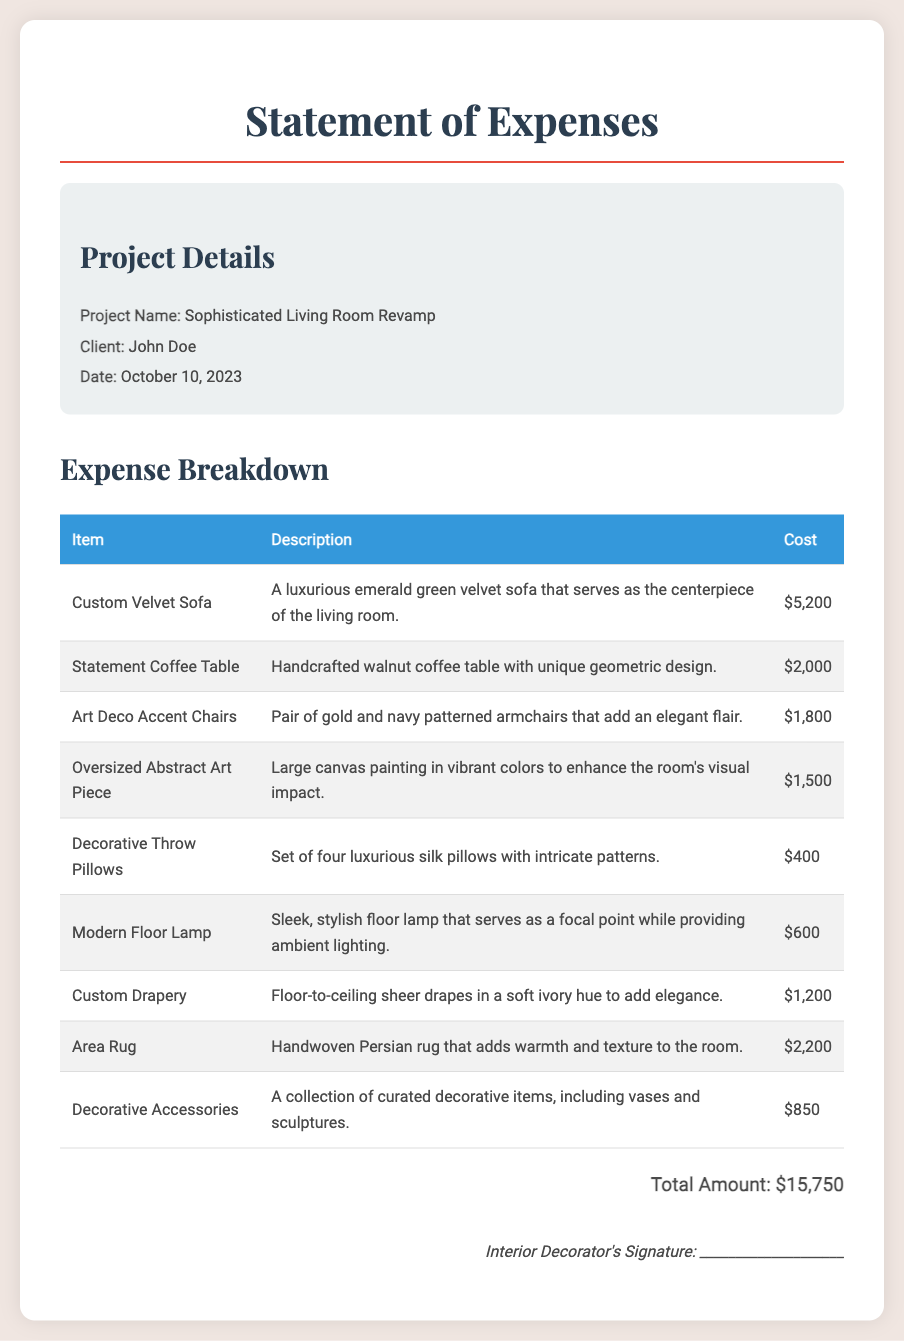What is the project name? The project name is listed at the top of the document under Project Details.
Answer: Sophisticated Living Room Revamp Who is the client? The client's name is mentioned in the Project Details section.
Answer: John Doe What is the date of the expense statement? The date is provided under Project Details at the top of the document.
Answer: October 10, 2023 How much does the Custom Velvet Sofa cost? The cost of the Custom Velvet Sofa is provided in the Expense Breakdown table.
Answer: $5,200 Which item has the highest cost? This requires comparing costs from the list provided in the document.
Answer: Custom Velvet Sofa What is the total amount of expenses? The total amount is stated at the end of the Expense Breakdown table.
Answer: $15,750 How many decorative throw pillows were purchased? The number of throw pillows is specified in the description under the corresponding item.
Answer: Four What style is the area rug described as? The style of the area rug can be found in the description of that item in the Expense Breakdown.
Answer: Handwoven Persian What does the statement coffee table feature? The features of the statement coffee table are listed in its description in the document.
Answer: Unique geometric design 